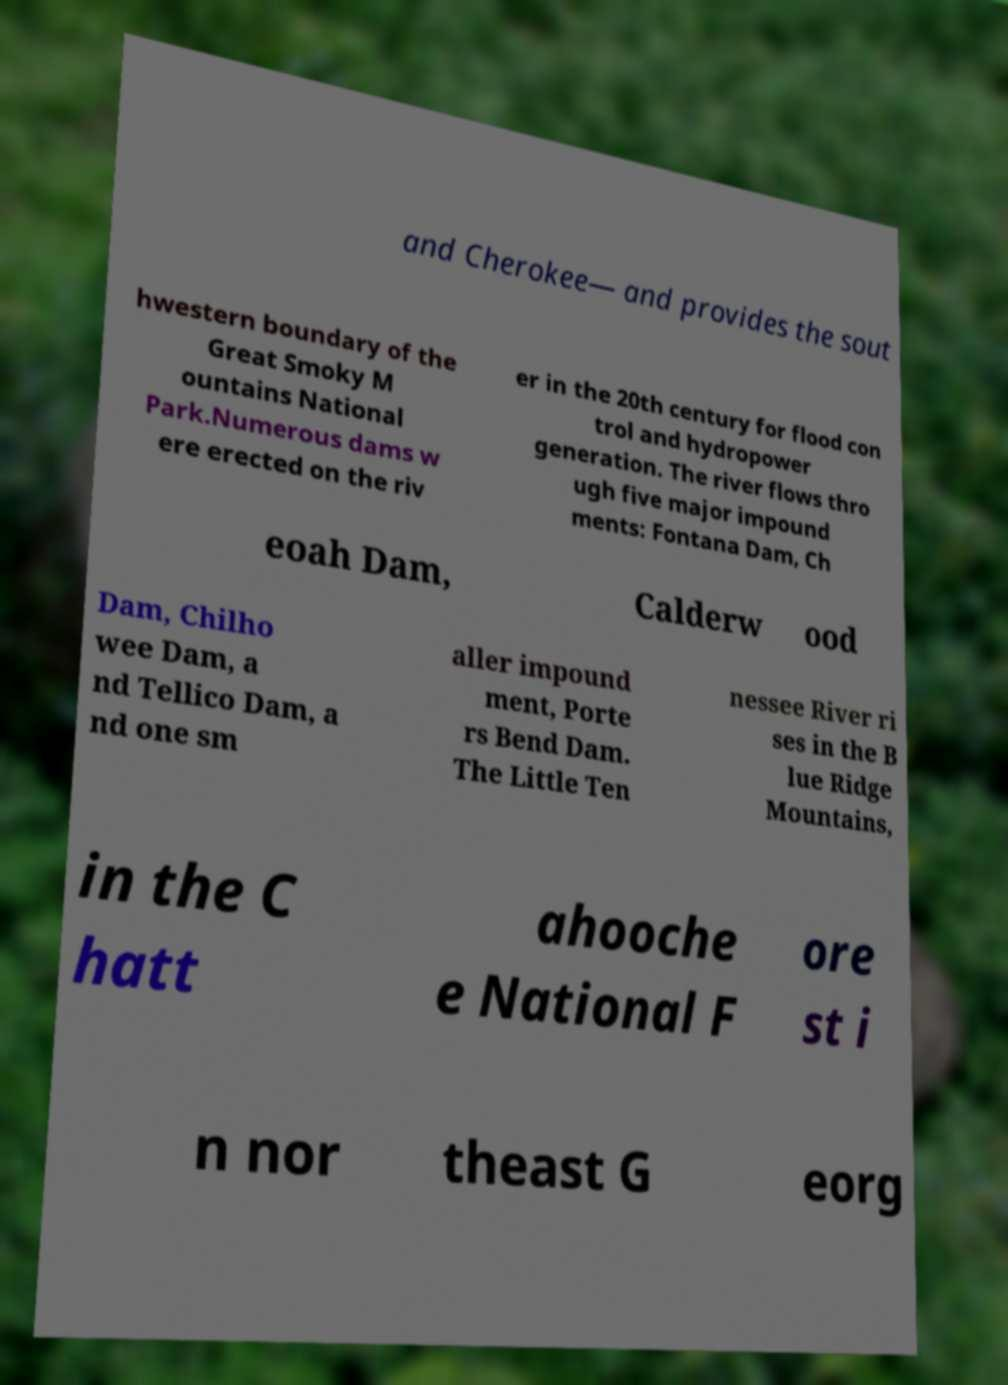Could you assist in decoding the text presented in this image and type it out clearly? and Cherokee— and provides the sout hwestern boundary of the Great Smoky M ountains National Park.Numerous dams w ere erected on the riv er in the 20th century for flood con trol and hydropower generation. The river flows thro ugh five major impound ments: Fontana Dam, Ch eoah Dam, Calderw ood Dam, Chilho wee Dam, a nd Tellico Dam, a nd one sm aller impound ment, Porte rs Bend Dam. The Little Ten nessee River ri ses in the B lue Ridge Mountains, in the C hatt ahooche e National F ore st i n nor theast G eorg 